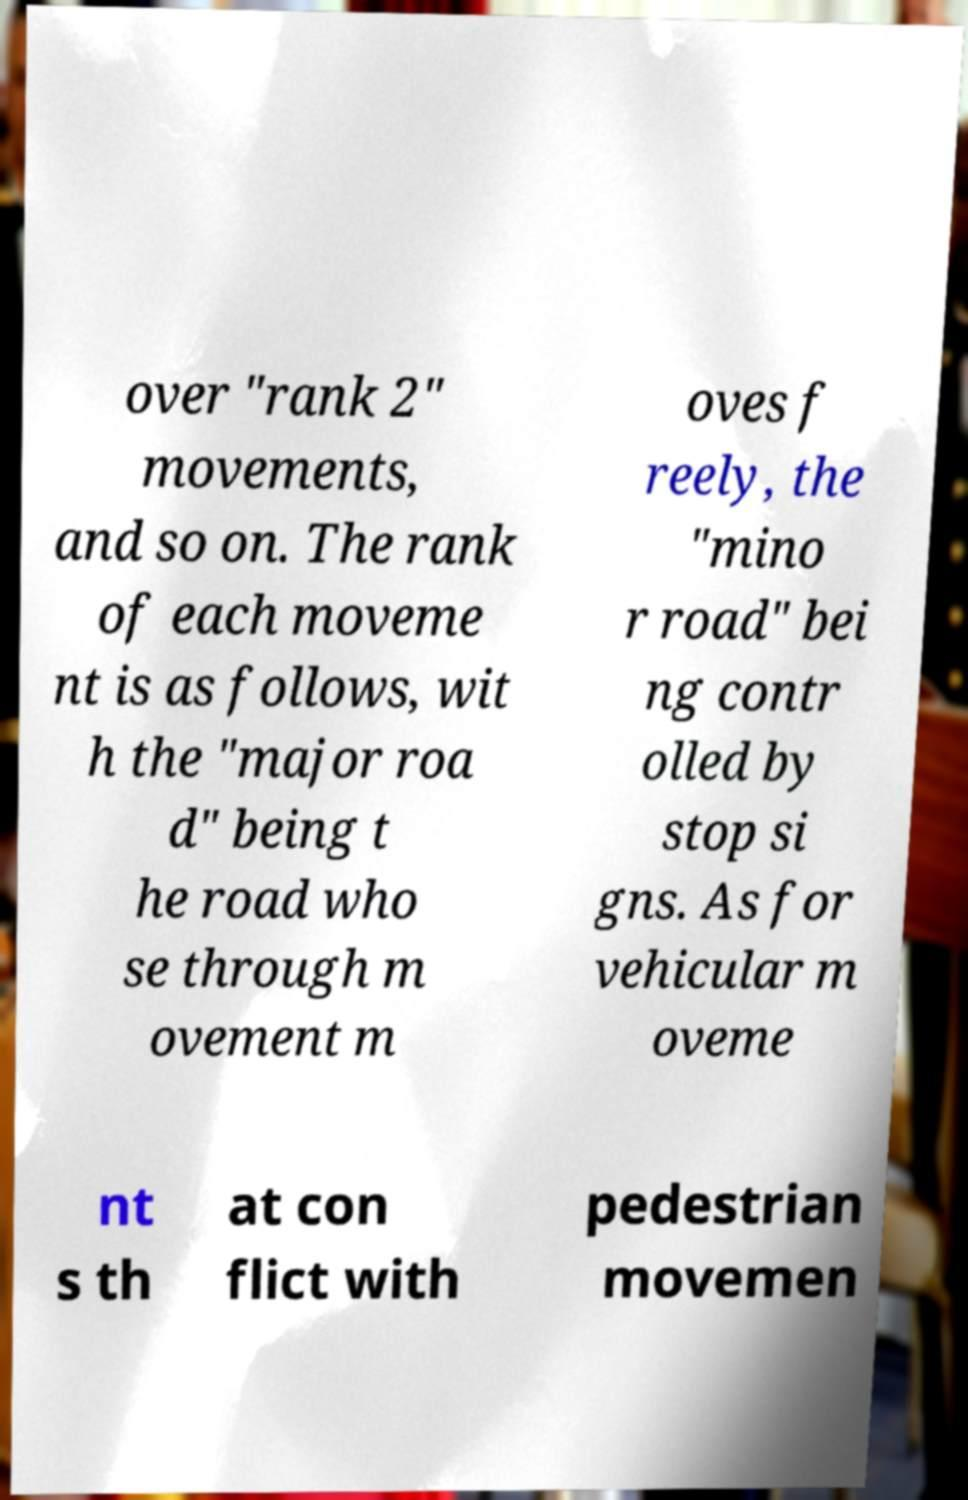Please identify and transcribe the text found in this image. over "rank 2" movements, and so on. The rank of each moveme nt is as follows, wit h the "major roa d" being t he road who se through m ovement m oves f reely, the "mino r road" bei ng contr olled by stop si gns. As for vehicular m oveme nt s th at con flict with pedestrian movemen 